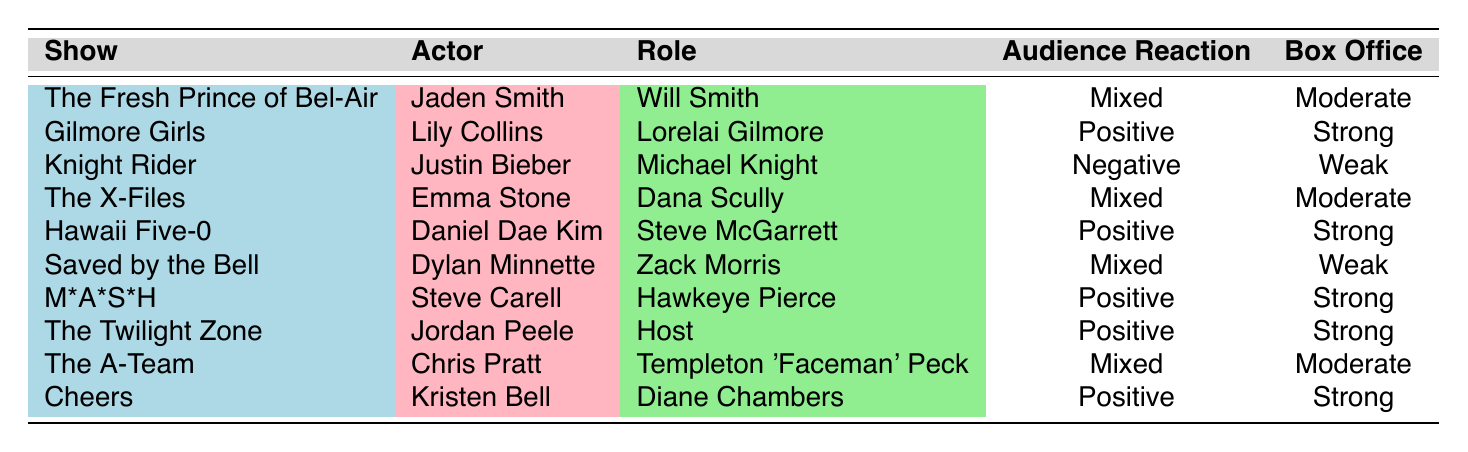What show features Jaden Smith as the lead actor? The table lists "The Fresh Prince of Bel-Air" where Jaden Smith is mentioned as the actor.
Answer: The Fresh Prince of Bel-Air How many shows received a positive audience reaction? Counting the shows with a "Positive" audience reaction from the table, we find Gilmore Girls, Hawaii Five-0, M*A*S*H, The Twilight Zone, and Cheers which totals to 5 shows.
Answer: 5 Which actor played a role in Hawaii Five-0? The table shows that Daniel Dae Kim is the actor for the role of Steve McGarrett in Hawaii Five-0.
Answer: Daniel Dae Kim Was the box office performance of Knight Rider strong? The table indicates that Knight Rider had a "Weak" box office performance, therefore the answer is no.
Answer: No What is the average box office performance status for the shows listed? Analyzing the box office performance for each show, we categorize them as Strong, Moderate, or Weak: Strong (5), Moderate (3), Weak (2). Since there are 10 shows, the average type leans towards Strong due to the higher count.
Answer: Average is Strong Which show had a mixed audience reaction and a moderate box office performance? Referring to the table, both The Fresh Prince of Bel-Air and The X-Files had a mixed audience reaction and also had moderate box office performances.
Answer: The Fresh Prince of Bel-Air and The X-Files Is there any show where the casting decision includes nostalgia appeal while introducing a new generation? The table specifically mentions "Saved by the Bell" with a decision motive centered around nostalgia appeal, so the answer is yes.
Answer: Yes What role did Emma Stone play in The X-Files? The table states that Emma Stone played the role of Dana Scully in The X-Files.
Answer: Dana Scully Which actor is connected with a negative audience reaction? Looking at the table, Justin Bieber in Knight Rider is marked with a negative audience reaction.
Answer: Justin Bieber in Knight Rider 